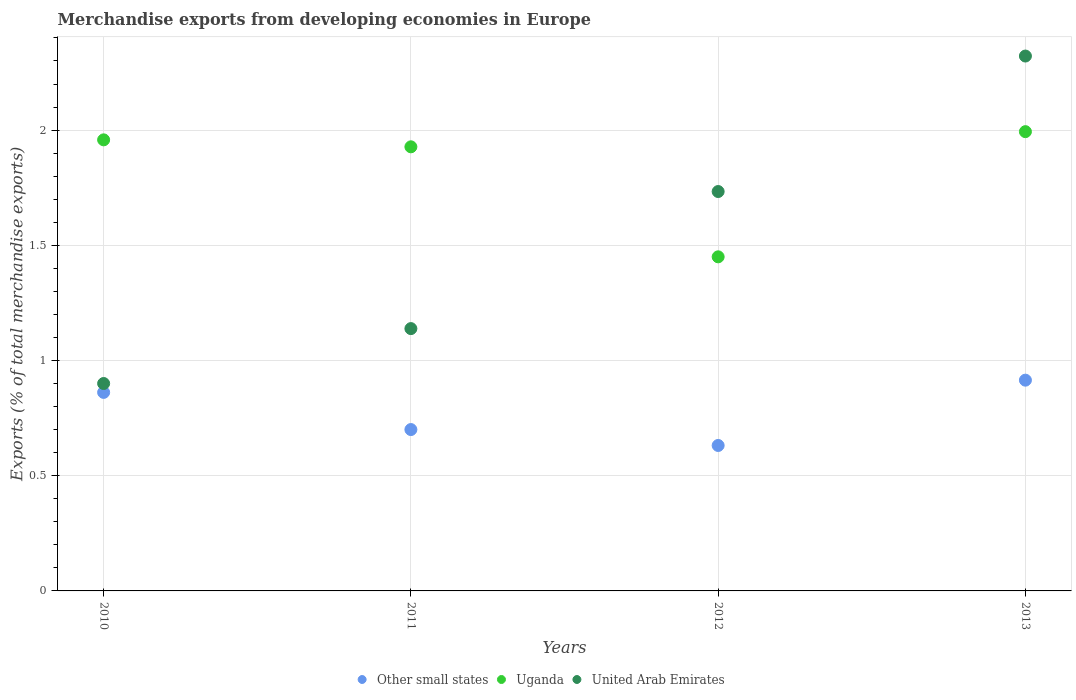What is the percentage of total merchandise exports in Uganda in 2012?
Your answer should be very brief. 1.45. Across all years, what is the maximum percentage of total merchandise exports in Uganda?
Your response must be concise. 1.99. Across all years, what is the minimum percentage of total merchandise exports in Other small states?
Your response must be concise. 0.63. What is the total percentage of total merchandise exports in Other small states in the graph?
Provide a succinct answer. 3.11. What is the difference between the percentage of total merchandise exports in Other small states in 2010 and that in 2011?
Your answer should be very brief. 0.16. What is the difference between the percentage of total merchandise exports in Uganda in 2011 and the percentage of total merchandise exports in United Arab Emirates in 2010?
Provide a short and direct response. 1.03. What is the average percentage of total merchandise exports in Other small states per year?
Give a very brief answer. 0.78. In the year 2013, what is the difference between the percentage of total merchandise exports in Uganda and percentage of total merchandise exports in United Arab Emirates?
Your response must be concise. -0.33. In how many years, is the percentage of total merchandise exports in Other small states greater than 0.9 %?
Your answer should be very brief. 1. What is the ratio of the percentage of total merchandise exports in Other small states in 2011 to that in 2012?
Your response must be concise. 1.11. Is the difference between the percentage of total merchandise exports in Uganda in 2010 and 2011 greater than the difference between the percentage of total merchandise exports in United Arab Emirates in 2010 and 2011?
Provide a short and direct response. Yes. What is the difference between the highest and the second highest percentage of total merchandise exports in Other small states?
Keep it short and to the point. 0.05. What is the difference between the highest and the lowest percentage of total merchandise exports in Uganda?
Make the answer very short. 0.54. In how many years, is the percentage of total merchandise exports in Other small states greater than the average percentage of total merchandise exports in Other small states taken over all years?
Provide a succinct answer. 2. Is it the case that in every year, the sum of the percentage of total merchandise exports in Other small states and percentage of total merchandise exports in Uganda  is greater than the percentage of total merchandise exports in United Arab Emirates?
Give a very brief answer. Yes. Does the percentage of total merchandise exports in Other small states monotonically increase over the years?
Offer a very short reply. No. How many dotlines are there?
Provide a short and direct response. 3. What is the difference between two consecutive major ticks on the Y-axis?
Offer a very short reply. 0.5. Where does the legend appear in the graph?
Provide a succinct answer. Bottom center. How many legend labels are there?
Keep it short and to the point. 3. What is the title of the graph?
Your answer should be very brief. Merchandise exports from developing economies in Europe. Does "Mauritania" appear as one of the legend labels in the graph?
Your response must be concise. No. What is the label or title of the Y-axis?
Provide a short and direct response. Exports (% of total merchandise exports). What is the Exports (% of total merchandise exports) of Other small states in 2010?
Offer a very short reply. 0.86. What is the Exports (% of total merchandise exports) in Uganda in 2010?
Keep it short and to the point. 1.96. What is the Exports (% of total merchandise exports) in United Arab Emirates in 2010?
Your answer should be very brief. 0.9. What is the Exports (% of total merchandise exports) of Other small states in 2011?
Make the answer very short. 0.7. What is the Exports (% of total merchandise exports) of Uganda in 2011?
Give a very brief answer. 1.93. What is the Exports (% of total merchandise exports) of United Arab Emirates in 2011?
Ensure brevity in your answer.  1.14. What is the Exports (% of total merchandise exports) in Other small states in 2012?
Ensure brevity in your answer.  0.63. What is the Exports (% of total merchandise exports) of Uganda in 2012?
Your answer should be very brief. 1.45. What is the Exports (% of total merchandise exports) in United Arab Emirates in 2012?
Ensure brevity in your answer.  1.73. What is the Exports (% of total merchandise exports) of Other small states in 2013?
Your answer should be very brief. 0.91. What is the Exports (% of total merchandise exports) of Uganda in 2013?
Keep it short and to the point. 1.99. What is the Exports (% of total merchandise exports) in United Arab Emirates in 2013?
Provide a short and direct response. 2.32. Across all years, what is the maximum Exports (% of total merchandise exports) of Other small states?
Give a very brief answer. 0.91. Across all years, what is the maximum Exports (% of total merchandise exports) in Uganda?
Provide a succinct answer. 1.99. Across all years, what is the maximum Exports (% of total merchandise exports) in United Arab Emirates?
Offer a very short reply. 2.32. Across all years, what is the minimum Exports (% of total merchandise exports) of Other small states?
Your response must be concise. 0.63. Across all years, what is the minimum Exports (% of total merchandise exports) in Uganda?
Ensure brevity in your answer.  1.45. Across all years, what is the minimum Exports (% of total merchandise exports) of United Arab Emirates?
Offer a very short reply. 0.9. What is the total Exports (% of total merchandise exports) in Other small states in the graph?
Provide a short and direct response. 3.11. What is the total Exports (% of total merchandise exports) in Uganda in the graph?
Your response must be concise. 7.33. What is the total Exports (% of total merchandise exports) of United Arab Emirates in the graph?
Your answer should be very brief. 6.09. What is the difference between the Exports (% of total merchandise exports) in Other small states in 2010 and that in 2011?
Your response must be concise. 0.16. What is the difference between the Exports (% of total merchandise exports) in Uganda in 2010 and that in 2011?
Offer a terse response. 0.03. What is the difference between the Exports (% of total merchandise exports) in United Arab Emirates in 2010 and that in 2011?
Give a very brief answer. -0.24. What is the difference between the Exports (% of total merchandise exports) of Other small states in 2010 and that in 2012?
Offer a very short reply. 0.23. What is the difference between the Exports (% of total merchandise exports) of Uganda in 2010 and that in 2012?
Keep it short and to the point. 0.51. What is the difference between the Exports (% of total merchandise exports) in United Arab Emirates in 2010 and that in 2012?
Your answer should be compact. -0.83. What is the difference between the Exports (% of total merchandise exports) of Other small states in 2010 and that in 2013?
Provide a succinct answer. -0.05. What is the difference between the Exports (% of total merchandise exports) of Uganda in 2010 and that in 2013?
Your response must be concise. -0.04. What is the difference between the Exports (% of total merchandise exports) in United Arab Emirates in 2010 and that in 2013?
Offer a terse response. -1.42. What is the difference between the Exports (% of total merchandise exports) in Other small states in 2011 and that in 2012?
Provide a short and direct response. 0.07. What is the difference between the Exports (% of total merchandise exports) in Uganda in 2011 and that in 2012?
Give a very brief answer. 0.48. What is the difference between the Exports (% of total merchandise exports) of United Arab Emirates in 2011 and that in 2012?
Keep it short and to the point. -0.59. What is the difference between the Exports (% of total merchandise exports) of Other small states in 2011 and that in 2013?
Your response must be concise. -0.21. What is the difference between the Exports (% of total merchandise exports) of Uganda in 2011 and that in 2013?
Your answer should be compact. -0.07. What is the difference between the Exports (% of total merchandise exports) of United Arab Emirates in 2011 and that in 2013?
Keep it short and to the point. -1.18. What is the difference between the Exports (% of total merchandise exports) in Other small states in 2012 and that in 2013?
Your response must be concise. -0.28. What is the difference between the Exports (% of total merchandise exports) of Uganda in 2012 and that in 2013?
Offer a terse response. -0.54. What is the difference between the Exports (% of total merchandise exports) of United Arab Emirates in 2012 and that in 2013?
Ensure brevity in your answer.  -0.59. What is the difference between the Exports (% of total merchandise exports) of Other small states in 2010 and the Exports (% of total merchandise exports) of Uganda in 2011?
Provide a succinct answer. -1.07. What is the difference between the Exports (% of total merchandise exports) in Other small states in 2010 and the Exports (% of total merchandise exports) in United Arab Emirates in 2011?
Provide a short and direct response. -0.28. What is the difference between the Exports (% of total merchandise exports) in Uganda in 2010 and the Exports (% of total merchandise exports) in United Arab Emirates in 2011?
Offer a terse response. 0.82. What is the difference between the Exports (% of total merchandise exports) of Other small states in 2010 and the Exports (% of total merchandise exports) of Uganda in 2012?
Keep it short and to the point. -0.59. What is the difference between the Exports (% of total merchandise exports) of Other small states in 2010 and the Exports (% of total merchandise exports) of United Arab Emirates in 2012?
Ensure brevity in your answer.  -0.87. What is the difference between the Exports (% of total merchandise exports) of Uganda in 2010 and the Exports (% of total merchandise exports) of United Arab Emirates in 2012?
Ensure brevity in your answer.  0.22. What is the difference between the Exports (% of total merchandise exports) in Other small states in 2010 and the Exports (% of total merchandise exports) in Uganda in 2013?
Offer a very short reply. -1.13. What is the difference between the Exports (% of total merchandise exports) of Other small states in 2010 and the Exports (% of total merchandise exports) of United Arab Emirates in 2013?
Your answer should be compact. -1.46. What is the difference between the Exports (% of total merchandise exports) of Uganda in 2010 and the Exports (% of total merchandise exports) of United Arab Emirates in 2013?
Keep it short and to the point. -0.36. What is the difference between the Exports (% of total merchandise exports) in Other small states in 2011 and the Exports (% of total merchandise exports) in Uganda in 2012?
Offer a very short reply. -0.75. What is the difference between the Exports (% of total merchandise exports) in Other small states in 2011 and the Exports (% of total merchandise exports) in United Arab Emirates in 2012?
Offer a very short reply. -1.03. What is the difference between the Exports (% of total merchandise exports) in Uganda in 2011 and the Exports (% of total merchandise exports) in United Arab Emirates in 2012?
Offer a terse response. 0.19. What is the difference between the Exports (% of total merchandise exports) in Other small states in 2011 and the Exports (% of total merchandise exports) in Uganda in 2013?
Offer a terse response. -1.29. What is the difference between the Exports (% of total merchandise exports) of Other small states in 2011 and the Exports (% of total merchandise exports) of United Arab Emirates in 2013?
Give a very brief answer. -1.62. What is the difference between the Exports (% of total merchandise exports) in Uganda in 2011 and the Exports (% of total merchandise exports) in United Arab Emirates in 2013?
Make the answer very short. -0.39. What is the difference between the Exports (% of total merchandise exports) in Other small states in 2012 and the Exports (% of total merchandise exports) in Uganda in 2013?
Keep it short and to the point. -1.36. What is the difference between the Exports (% of total merchandise exports) of Other small states in 2012 and the Exports (% of total merchandise exports) of United Arab Emirates in 2013?
Give a very brief answer. -1.69. What is the difference between the Exports (% of total merchandise exports) in Uganda in 2012 and the Exports (% of total merchandise exports) in United Arab Emirates in 2013?
Your response must be concise. -0.87. What is the average Exports (% of total merchandise exports) of Other small states per year?
Your response must be concise. 0.78. What is the average Exports (% of total merchandise exports) of Uganda per year?
Your answer should be very brief. 1.83. What is the average Exports (% of total merchandise exports) in United Arab Emirates per year?
Provide a succinct answer. 1.52. In the year 2010, what is the difference between the Exports (% of total merchandise exports) of Other small states and Exports (% of total merchandise exports) of Uganda?
Provide a short and direct response. -1.1. In the year 2010, what is the difference between the Exports (% of total merchandise exports) in Other small states and Exports (% of total merchandise exports) in United Arab Emirates?
Provide a short and direct response. -0.04. In the year 2010, what is the difference between the Exports (% of total merchandise exports) in Uganda and Exports (% of total merchandise exports) in United Arab Emirates?
Your response must be concise. 1.06. In the year 2011, what is the difference between the Exports (% of total merchandise exports) in Other small states and Exports (% of total merchandise exports) in Uganda?
Ensure brevity in your answer.  -1.23. In the year 2011, what is the difference between the Exports (% of total merchandise exports) of Other small states and Exports (% of total merchandise exports) of United Arab Emirates?
Your answer should be compact. -0.44. In the year 2011, what is the difference between the Exports (% of total merchandise exports) of Uganda and Exports (% of total merchandise exports) of United Arab Emirates?
Give a very brief answer. 0.79. In the year 2012, what is the difference between the Exports (% of total merchandise exports) of Other small states and Exports (% of total merchandise exports) of Uganda?
Ensure brevity in your answer.  -0.82. In the year 2012, what is the difference between the Exports (% of total merchandise exports) of Other small states and Exports (% of total merchandise exports) of United Arab Emirates?
Make the answer very short. -1.1. In the year 2012, what is the difference between the Exports (% of total merchandise exports) in Uganda and Exports (% of total merchandise exports) in United Arab Emirates?
Keep it short and to the point. -0.28. In the year 2013, what is the difference between the Exports (% of total merchandise exports) of Other small states and Exports (% of total merchandise exports) of Uganda?
Offer a very short reply. -1.08. In the year 2013, what is the difference between the Exports (% of total merchandise exports) in Other small states and Exports (% of total merchandise exports) in United Arab Emirates?
Provide a succinct answer. -1.41. In the year 2013, what is the difference between the Exports (% of total merchandise exports) of Uganda and Exports (% of total merchandise exports) of United Arab Emirates?
Offer a very short reply. -0.33. What is the ratio of the Exports (% of total merchandise exports) of Other small states in 2010 to that in 2011?
Offer a terse response. 1.23. What is the ratio of the Exports (% of total merchandise exports) of Uganda in 2010 to that in 2011?
Your response must be concise. 1.02. What is the ratio of the Exports (% of total merchandise exports) of United Arab Emirates in 2010 to that in 2011?
Offer a very short reply. 0.79. What is the ratio of the Exports (% of total merchandise exports) of Other small states in 2010 to that in 2012?
Your response must be concise. 1.36. What is the ratio of the Exports (% of total merchandise exports) in Uganda in 2010 to that in 2012?
Ensure brevity in your answer.  1.35. What is the ratio of the Exports (% of total merchandise exports) of United Arab Emirates in 2010 to that in 2012?
Offer a very short reply. 0.52. What is the ratio of the Exports (% of total merchandise exports) in Other small states in 2010 to that in 2013?
Offer a terse response. 0.94. What is the ratio of the Exports (% of total merchandise exports) in Uganda in 2010 to that in 2013?
Offer a very short reply. 0.98. What is the ratio of the Exports (% of total merchandise exports) in United Arab Emirates in 2010 to that in 2013?
Give a very brief answer. 0.39. What is the ratio of the Exports (% of total merchandise exports) in Other small states in 2011 to that in 2012?
Provide a short and direct response. 1.11. What is the ratio of the Exports (% of total merchandise exports) of Uganda in 2011 to that in 2012?
Provide a succinct answer. 1.33. What is the ratio of the Exports (% of total merchandise exports) in United Arab Emirates in 2011 to that in 2012?
Keep it short and to the point. 0.66. What is the ratio of the Exports (% of total merchandise exports) of Other small states in 2011 to that in 2013?
Offer a very short reply. 0.77. What is the ratio of the Exports (% of total merchandise exports) in Uganda in 2011 to that in 2013?
Ensure brevity in your answer.  0.97. What is the ratio of the Exports (% of total merchandise exports) in United Arab Emirates in 2011 to that in 2013?
Your answer should be very brief. 0.49. What is the ratio of the Exports (% of total merchandise exports) in Other small states in 2012 to that in 2013?
Provide a succinct answer. 0.69. What is the ratio of the Exports (% of total merchandise exports) of Uganda in 2012 to that in 2013?
Provide a succinct answer. 0.73. What is the ratio of the Exports (% of total merchandise exports) in United Arab Emirates in 2012 to that in 2013?
Give a very brief answer. 0.75. What is the difference between the highest and the second highest Exports (% of total merchandise exports) of Other small states?
Make the answer very short. 0.05. What is the difference between the highest and the second highest Exports (% of total merchandise exports) of Uganda?
Your response must be concise. 0.04. What is the difference between the highest and the second highest Exports (% of total merchandise exports) of United Arab Emirates?
Give a very brief answer. 0.59. What is the difference between the highest and the lowest Exports (% of total merchandise exports) of Other small states?
Keep it short and to the point. 0.28. What is the difference between the highest and the lowest Exports (% of total merchandise exports) of Uganda?
Ensure brevity in your answer.  0.54. What is the difference between the highest and the lowest Exports (% of total merchandise exports) in United Arab Emirates?
Provide a succinct answer. 1.42. 